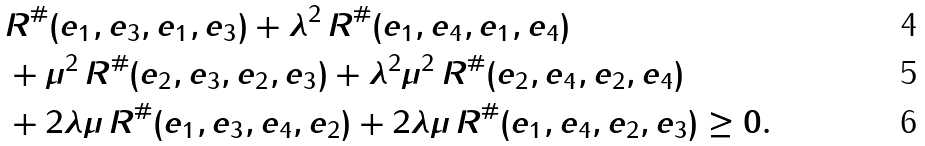Convert formula to latex. <formula><loc_0><loc_0><loc_500><loc_500>& R ^ { \# } ( e _ { 1 } , e _ { 3 } , e _ { 1 } , e _ { 3 } ) + \lambda ^ { 2 } \, R ^ { \# } ( e _ { 1 } , e _ { 4 } , e _ { 1 } , e _ { 4 } ) \\ & + \mu ^ { 2 } \, R ^ { \# } ( e _ { 2 } , e _ { 3 } , e _ { 2 } , e _ { 3 } ) + \lambda ^ { 2 } \mu ^ { 2 } \, R ^ { \# } ( e _ { 2 } , e _ { 4 } , e _ { 2 } , e _ { 4 } ) \\ & + 2 \lambda \mu \, R ^ { \# } ( e _ { 1 } , e _ { 3 } , e _ { 4 } , e _ { 2 } ) + 2 \lambda \mu \, R ^ { \# } ( e _ { 1 } , e _ { 4 } , e _ { 2 } , e _ { 3 } ) \geq 0 .</formula> 